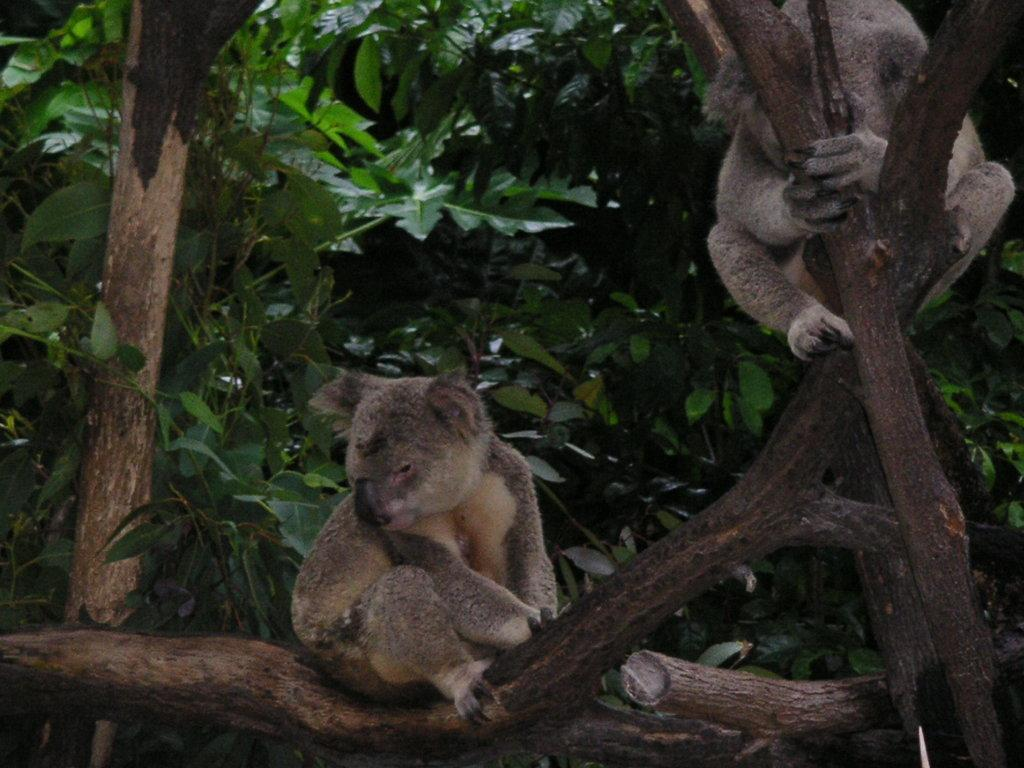What animals are present in the image? There are koala bears in the image. Where are the koala bears located? The koala bears are sitting on a tree. What can be seen in the background of the image? There are trees visible in the background of the image. What type of baby clothing is visible in the image? There is no baby clothing present in the image; it features koala bears sitting on a tree. 